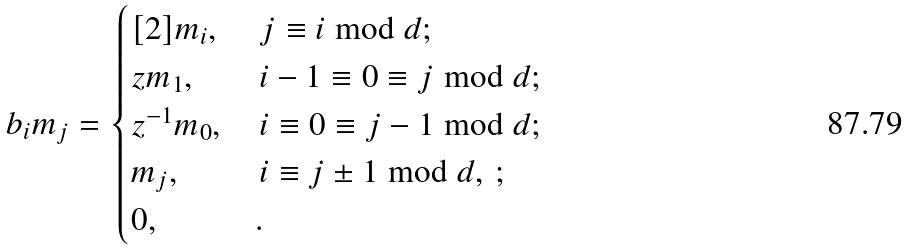<formula> <loc_0><loc_0><loc_500><loc_500>b _ { i } m _ { j } = \begin{cases} [ 2 ] m _ { i } , & \, j \equiv i \bmod d ; \\ z m _ { 1 } , & \, i - 1 \equiv 0 \equiv j \bmod d ; \\ z ^ { - 1 } m _ { 0 } , & \, i \equiv 0 \equiv j - 1 \bmod d ; \\ m _ { j } , & \, i \equiv j \pm 1 \bmod d , \, ; \\ 0 , & . \end{cases}</formula> 